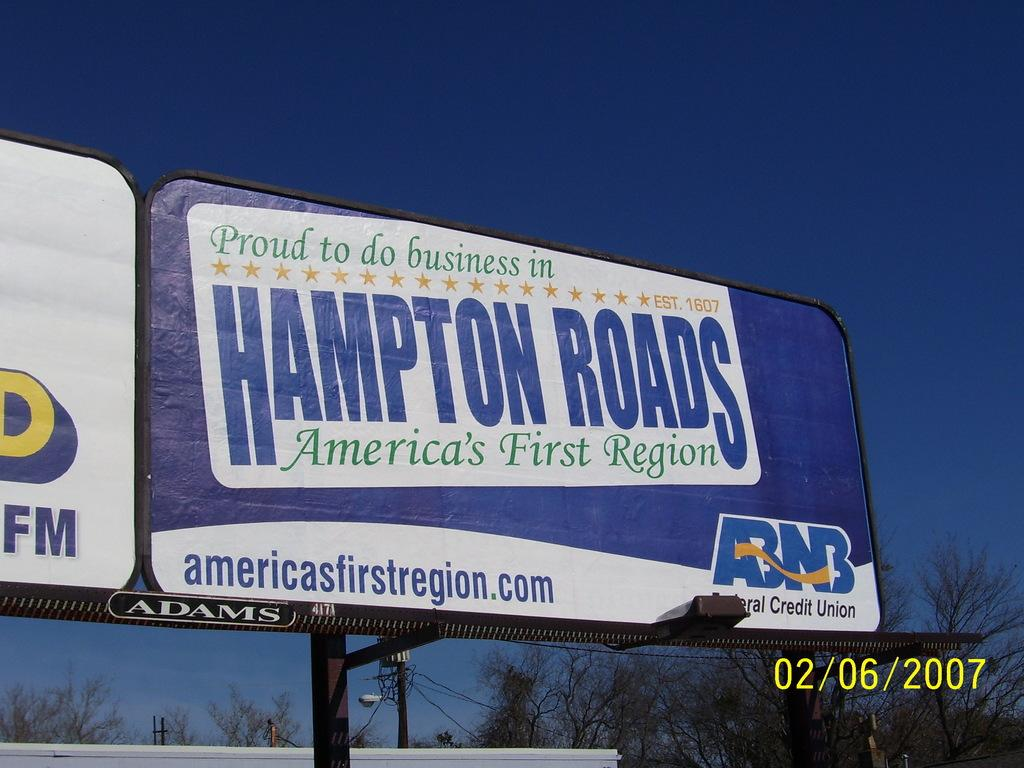<image>
Provide a brief description of the given image. a blue Hampton Roads billboard dated in the year 2007 